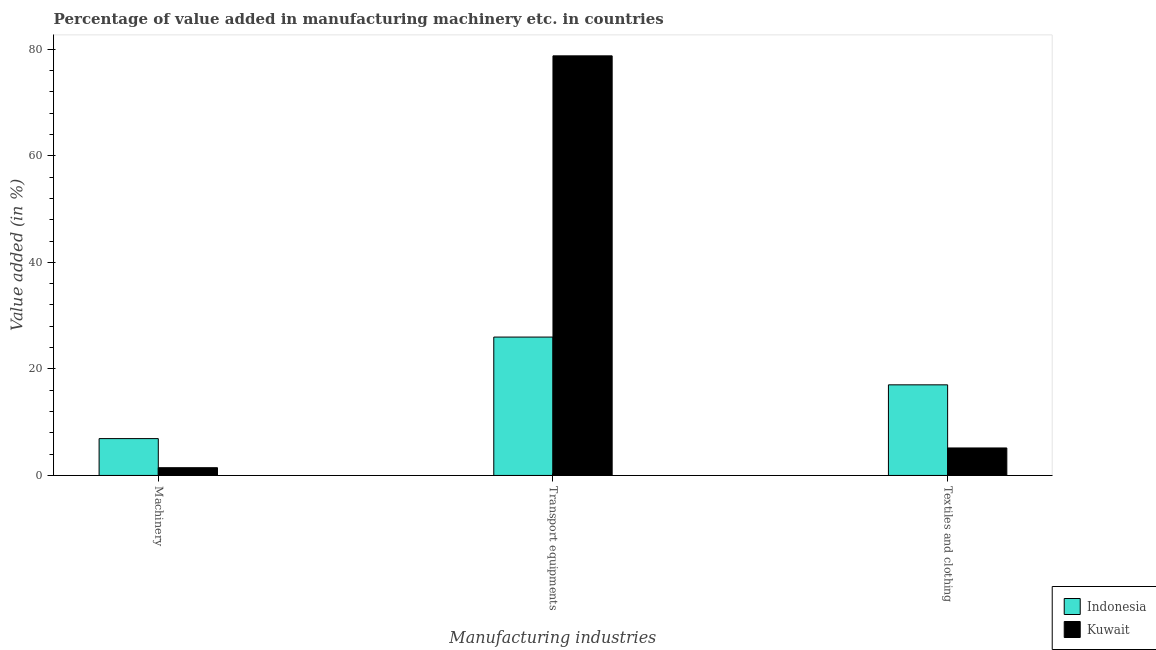Are the number of bars per tick equal to the number of legend labels?
Provide a short and direct response. Yes. How many bars are there on the 1st tick from the left?
Keep it short and to the point. 2. How many bars are there on the 2nd tick from the right?
Your answer should be very brief. 2. What is the label of the 1st group of bars from the left?
Provide a short and direct response. Machinery. What is the value added in manufacturing textile and clothing in Kuwait?
Your answer should be very brief. 5.16. Across all countries, what is the maximum value added in manufacturing machinery?
Offer a terse response. 6.92. Across all countries, what is the minimum value added in manufacturing textile and clothing?
Offer a terse response. 5.16. In which country was the value added in manufacturing textile and clothing maximum?
Provide a short and direct response. Indonesia. In which country was the value added in manufacturing transport equipments minimum?
Your response must be concise. Indonesia. What is the total value added in manufacturing textile and clothing in the graph?
Offer a very short reply. 22.17. What is the difference between the value added in manufacturing transport equipments in Kuwait and that in Indonesia?
Your answer should be very brief. 52.79. What is the difference between the value added in manufacturing machinery in Indonesia and the value added in manufacturing textile and clothing in Kuwait?
Keep it short and to the point. 1.76. What is the average value added in manufacturing textile and clothing per country?
Ensure brevity in your answer.  11.08. What is the difference between the value added in manufacturing machinery and value added in manufacturing textile and clothing in Indonesia?
Your answer should be very brief. -10.09. What is the ratio of the value added in manufacturing machinery in Indonesia to that in Kuwait?
Offer a very short reply. 4.76. What is the difference between the highest and the second highest value added in manufacturing textile and clothing?
Your response must be concise. 11.85. What is the difference between the highest and the lowest value added in manufacturing textile and clothing?
Provide a succinct answer. 11.85. Is the sum of the value added in manufacturing transport equipments in Indonesia and Kuwait greater than the maximum value added in manufacturing textile and clothing across all countries?
Keep it short and to the point. Yes. What does the 1st bar from the left in Textiles and clothing represents?
Your answer should be compact. Indonesia. Is it the case that in every country, the sum of the value added in manufacturing machinery and value added in manufacturing transport equipments is greater than the value added in manufacturing textile and clothing?
Provide a succinct answer. Yes. How many bars are there?
Keep it short and to the point. 6. What is the difference between two consecutive major ticks on the Y-axis?
Provide a short and direct response. 20. Are the values on the major ticks of Y-axis written in scientific E-notation?
Offer a very short reply. No. What is the title of the graph?
Provide a short and direct response. Percentage of value added in manufacturing machinery etc. in countries. What is the label or title of the X-axis?
Keep it short and to the point. Manufacturing industries. What is the label or title of the Y-axis?
Offer a terse response. Value added (in %). What is the Value added (in %) in Indonesia in Machinery?
Provide a short and direct response. 6.92. What is the Value added (in %) in Kuwait in Machinery?
Keep it short and to the point. 1.45. What is the Value added (in %) in Indonesia in Transport equipments?
Your answer should be compact. 25.98. What is the Value added (in %) of Kuwait in Transport equipments?
Provide a succinct answer. 78.77. What is the Value added (in %) of Indonesia in Textiles and clothing?
Ensure brevity in your answer.  17.01. What is the Value added (in %) of Kuwait in Textiles and clothing?
Your response must be concise. 5.16. Across all Manufacturing industries, what is the maximum Value added (in %) of Indonesia?
Give a very brief answer. 25.98. Across all Manufacturing industries, what is the maximum Value added (in %) of Kuwait?
Keep it short and to the point. 78.77. Across all Manufacturing industries, what is the minimum Value added (in %) of Indonesia?
Your answer should be compact. 6.92. Across all Manufacturing industries, what is the minimum Value added (in %) in Kuwait?
Keep it short and to the point. 1.45. What is the total Value added (in %) of Indonesia in the graph?
Offer a terse response. 49.9. What is the total Value added (in %) of Kuwait in the graph?
Offer a very short reply. 85.38. What is the difference between the Value added (in %) of Indonesia in Machinery and that in Transport equipments?
Make the answer very short. -19.06. What is the difference between the Value added (in %) of Kuwait in Machinery and that in Transport equipments?
Provide a short and direct response. -77.32. What is the difference between the Value added (in %) in Indonesia in Machinery and that in Textiles and clothing?
Offer a terse response. -10.09. What is the difference between the Value added (in %) of Kuwait in Machinery and that in Textiles and clothing?
Offer a terse response. -3.71. What is the difference between the Value added (in %) of Indonesia in Transport equipments and that in Textiles and clothing?
Your answer should be compact. 8.97. What is the difference between the Value added (in %) in Kuwait in Transport equipments and that in Textiles and clothing?
Keep it short and to the point. 73.61. What is the difference between the Value added (in %) in Indonesia in Machinery and the Value added (in %) in Kuwait in Transport equipments?
Offer a very short reply. -71.85. What is the difference between the Value added (in %) in Indonesia in Machinery and the Value added (in %) in Kuwait in Textiles and clothing?
Ensure brevity in your answer.  1.76. What is the difference between the Value added (in %) in Indonesia in Transport equipments and the Value added (in %) in Kuwait in Textiles and clothing?
Your response must be concise. 20.82. What is the average Value added (in %) of Indonesia per Manufacturing industries?
Keep it short and to the point. 16.63. What is the average Value added (in %) of Kuwait per Manufacturing industries?
Offer a terse response. 28.46. What is the difference between the Value added (in %) in Indonesia and Value added (in %) in Kuwait in Machinery?
Give a very brief answer. 5.46. What is the difference between the Value added (in %) in Indonesia and Value added (in %) in Kuwait in Transport equipments?
Keep it short and to the point. -52.79. What is the difference between the Value added (in %) in Indonesia and Value added (in %) in Kuwait in Textiles and clothing?
Offer a terse response. 11.85. What is the ratio of the Value added (in %) of Indonesia in Machinery to that in Transport equipments?
Offer a very short reply. 0.27. What is the ratio of the Value added (in %) of Kuwait in Machinery to that in Transport equipments?
Offer a very short reply. 0.02. What is the ratio of the Value added (in %) in Indonesia in Machinery to that in Textiles and clothing?
Your response must be concise. 0.41. What is the ratio of the Value added (in %) of Kuwait in Machinery to that in Textiles and clothing?
Your answer should be very brief. 0.28. What is the ratio of the Value added (in %) of Indonesia in Transport equipments to that in Textiles and clothing?
Provide a short and direct response. 1.53. What is the ratio of the Value added (in %) in Kuwait in Transport equipments to that in Textiles and clothing?
Offer a very short reply. 15.27. What is the difference between the highest and the second highest Value added (in %) of Indonesia?
Give a very brief answer. 8.97. What is the difference between the highest and the second highest Value added (in %) of Kuwait?
Ensure brevity in your answer.  73.61. What is the difference between the highest and the lowest Value added (in %) in Indonesia?
Ensure brevity in your answer.  19.06. What is the difference between the highest and the lowest Value added (in %) of Kuwait?
Your answer should be compact. 77.32. 